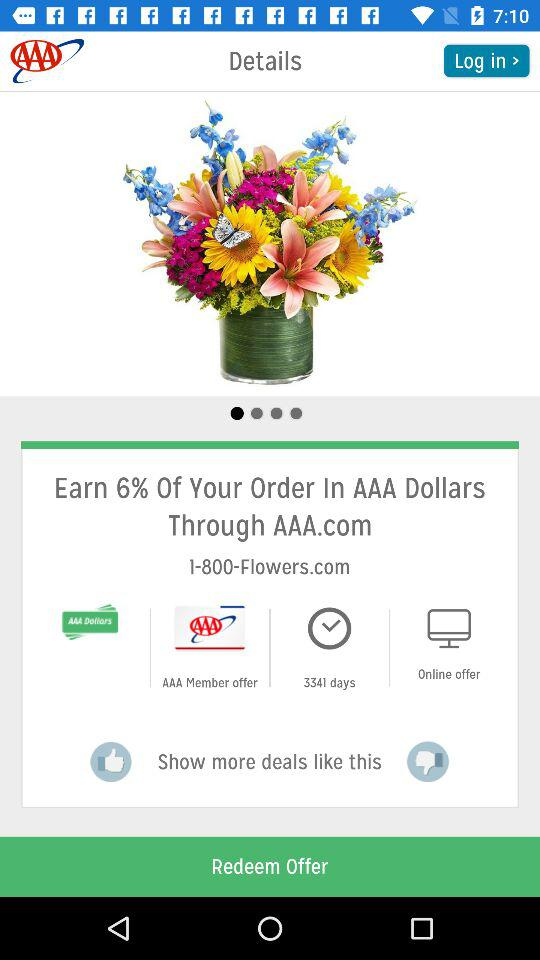How many days is the AAA member offer valid for?
Answer the question using a single word or phrase. 3341 days 